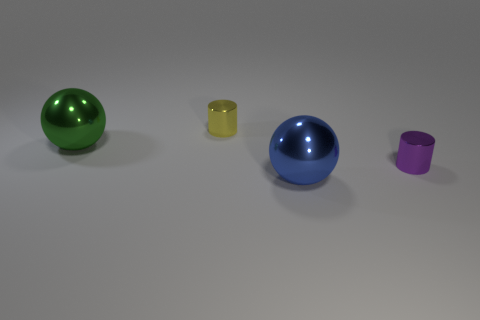What number of metallic objects are both behind the large blue sphere and left of the tiny purple shiny cylinder?
Your answer should be compact. 2. How many objects are shiny things on the right side of the yellow cylinder or objects that are to the right of the green shiny object?
Your answer should be compact. 3. What number of other things are the same shape as the blue metallic thing?
Give a very brief answer. 1. What number of other things are there of the same size as the green metallic ball?
Your answer should be very brief. 1. Do the purple object and the green ball have the same material?
Provide a short and direct response. Yes. There is a tiny object that is behind the shiny thing on the right side of the blue object; what is its color?
Keep it short and to the point. Yellow. The other metal object that is the same shape as the purple metal thing is what size?
Offer a very short reply. Small. How many things are on the right side of the large ball that is on the right side of the large thing that is behind the small purple shiny cylinder?
Offer a very short reply. 1. Is the number of cyan shiny cubes greater than the number of large green objects?
Provide a short and direct response. No. What number of green balls are there?
Provide a succinct answer. 1. 